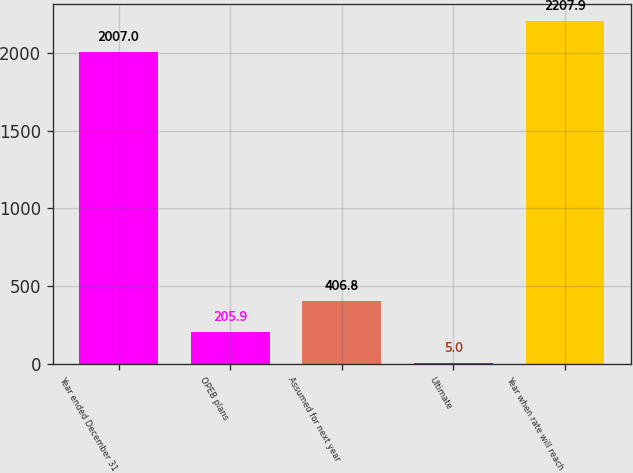Convert chart to OTSL. <chart><loc_0><loc_0><loc_500><loc_500><bar_chart><fcel>Year ended December 31<fcel>OPEB plans<fcel>Assumed for next year<fcel>Ultimate<fcel>Year when rate will reach<nl><fcel>2007<fcel>205.9<fcel>406.8<fcel>5<fcel>2207.9<nl></chart> 